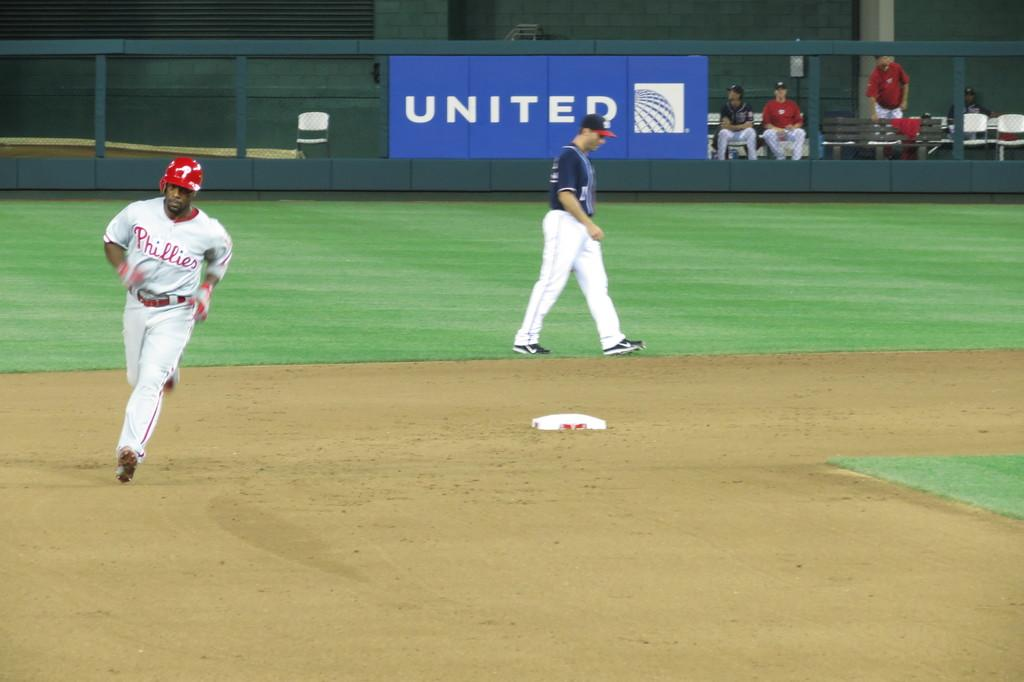<image>
Share a concise interpretation of the image provided. a Phillies baseball player making a run with a United banner on the fence behind him 